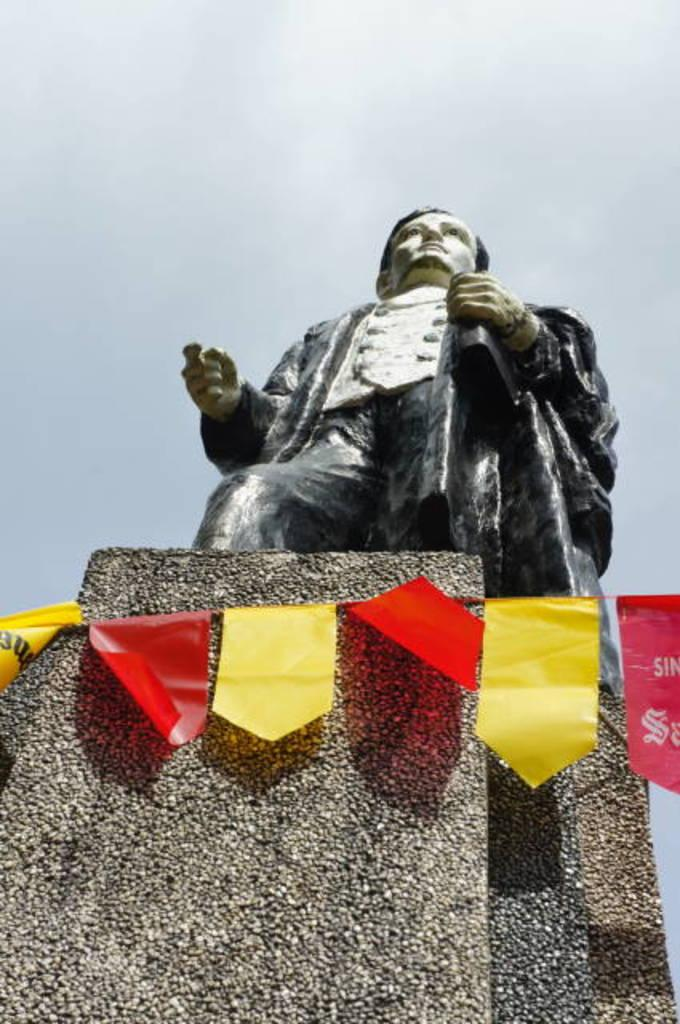What is the main subject of the image? There is a statue in the image. Where is the statue located? The statue is on a rock. What else can be seen in the image besides the statue? There is a decoration in the image. What is the condition of the sky in the image? The sky is clear in the image. Can you tell me what type of jeans the statue is wearing in the image? There is no mention of jeans in the image, as the subject is a statue and not a person. --- 